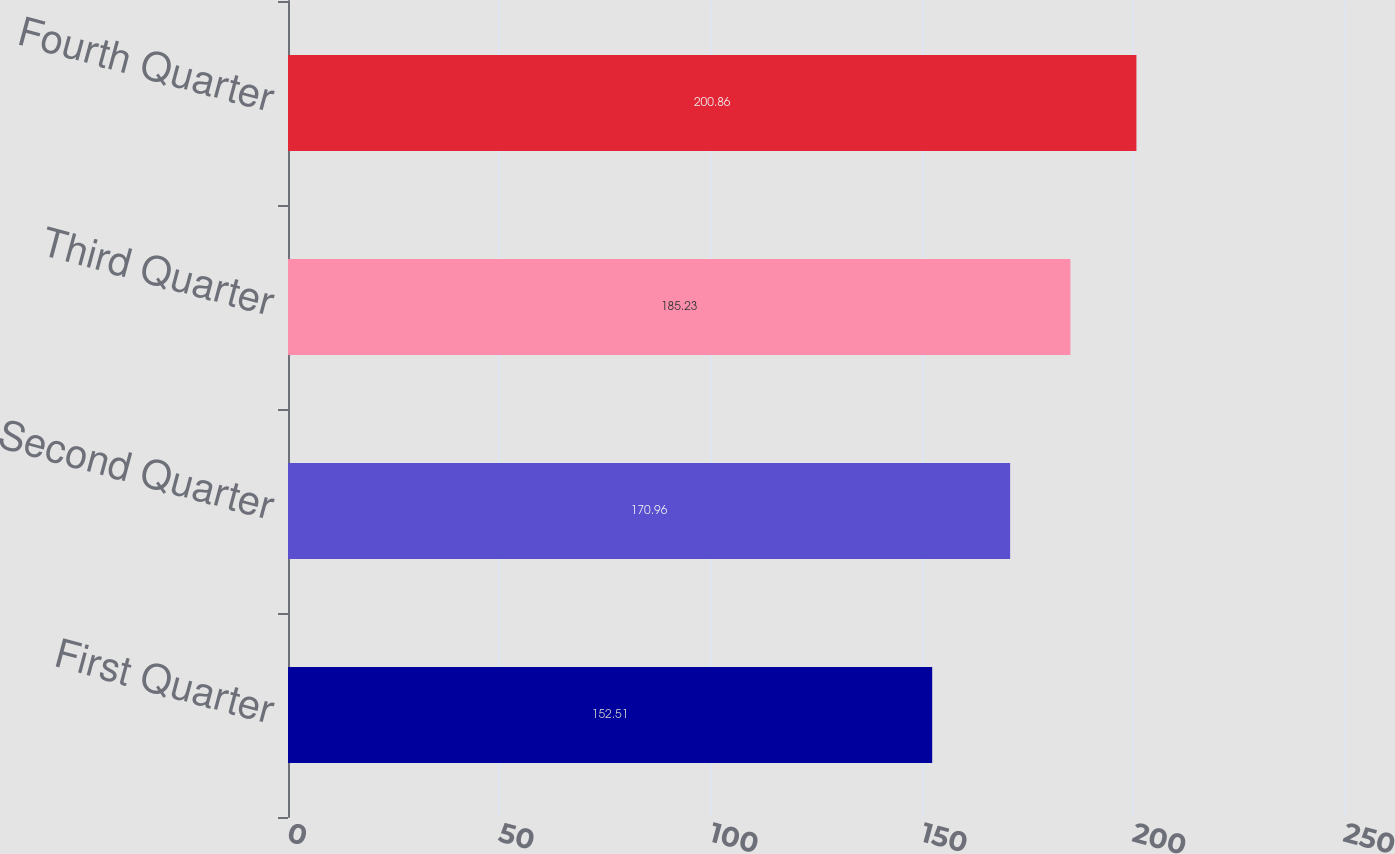Convert chart to OTSL. <chart><loc_0><loc_0><loc_500><loc_500><bar_chart><fcel>First Quarter<fcel>Second Quarter<fcel>Third Quarter<fcel>Fourth Quarter<nl><fcel>152.51<fcel>170.96<fcel>185.23<fcel>200.86<nl></chart> 